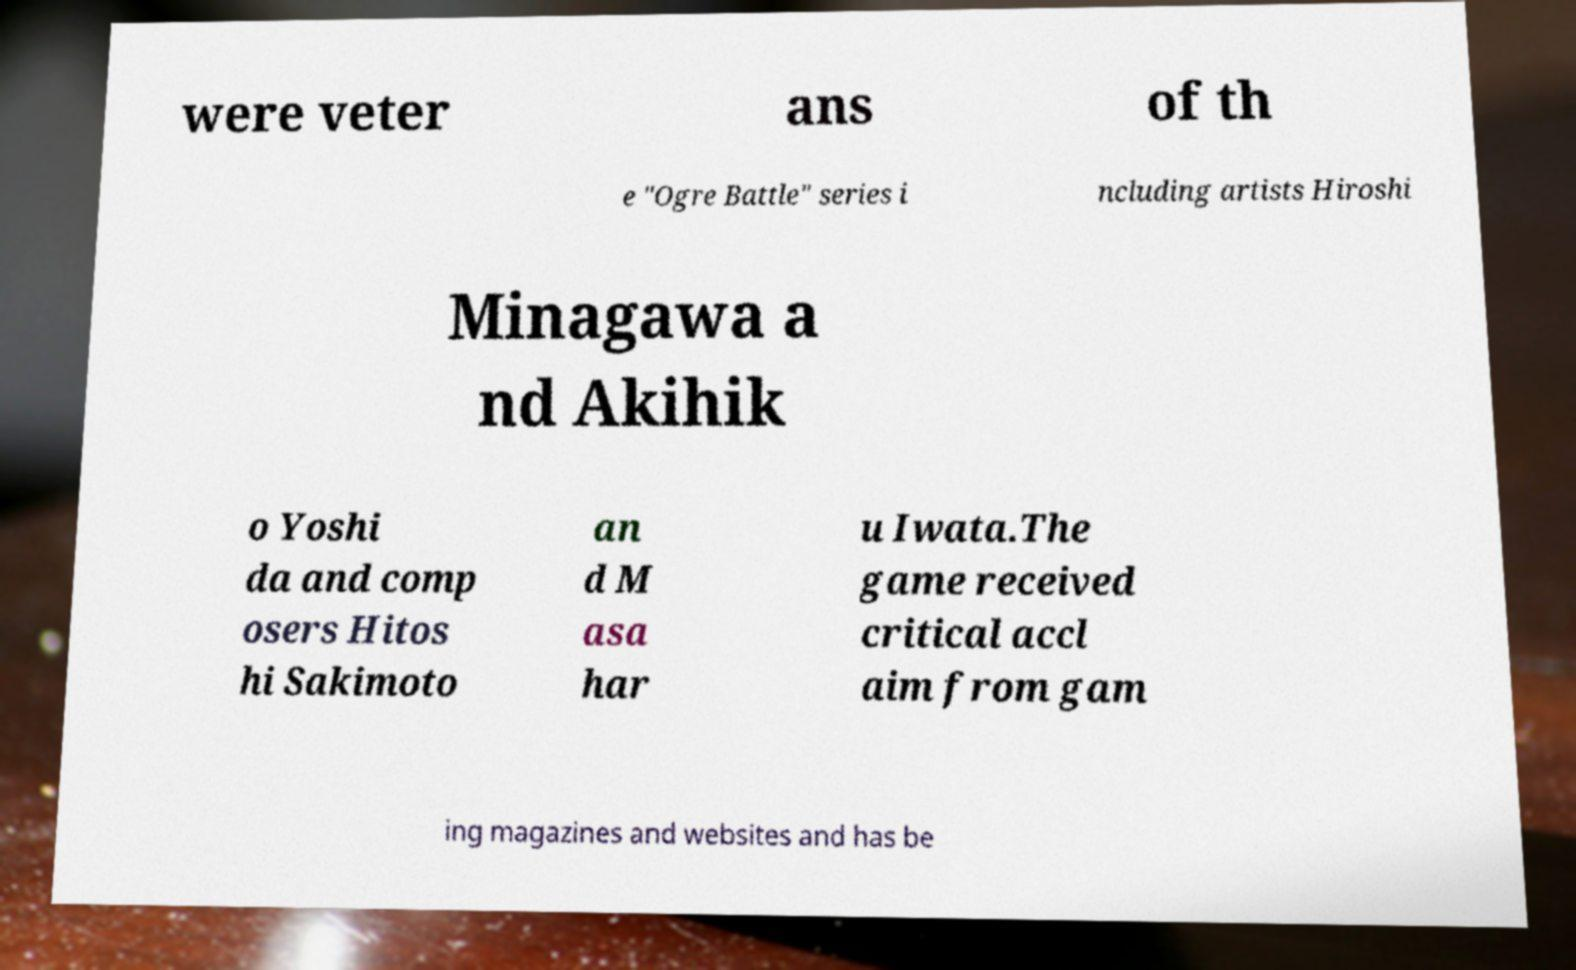Could you extract and type out the text from this image? were veter ans of th e "Ogre Battle" series i ncluding artists Hiroshi Minagawa a nd Akihik o Yoshi da and comp osers Hitos hi Sakimoto an d M asa har u Iwata.The game received critical accl aim from gam ing magazines and websites and has be 